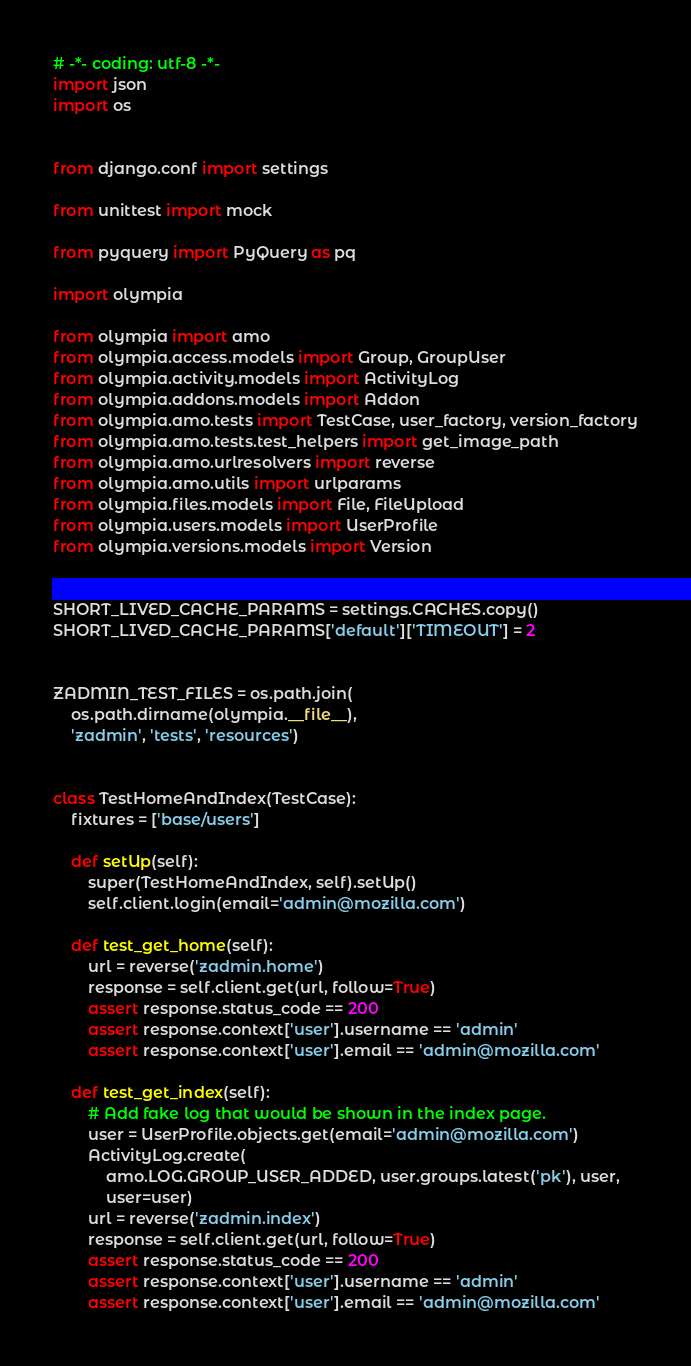Convert code to text. <code><loc_0><loc_0><loc_500><loc_500><_Python_># -*- coding: utf-8 -*-
import json
import os


from django.conf import settings

from unittest import mock

from pyquery import PyQuery as pq

import olympia

from olympia import amo
from olympia.access.models import Group, GroupUser
from olympia.activity.models import ActivityLog
from olympia.addons.models import Addon
from olympia.amo.tests import TestCase, user_factory, version_factory
from olympia.amo.tests.test_helpers import get_image_path
from olympia.amo.urlresolvers import reverse
from olympia.amo.utils import urlparams
from olympia.files.models import File, FileUpload
from olympia.users.models import UserProfile
from olympia.versions.models import Version


SHORT_LIVED_CACHE_PARAMS = settings.CACHES.copy()
SHORT_LIVED_CACHE_PARAMS['default']['TIMEOUT'] = 2


ZADMIN_TEST_FILES = os.path.join(
    os.path.dirname(olympia.__file__),
    'zadmin', 'tests', 'resources')


class TestHomeAndIndex(TestCase):
    fixtures = ['base/users']

    def setUp(self):
        super(TestHomeAndIndex, self).setUp()
        self.client.login(email='admin@mozilla.com')

    def test_get_home(self):
        url = reverse('zadmin.home')
        response = self.client.get(url, follow=True)
        assert response.status_code == 200
        assert response.context['user'].username == 'admin'
        assert response.context['user'].email == 'admin@mozilla.com'

    def test_get_index(self):
        # Add fake log that would be shown in the index page.
        user = UserProfile.objects.get(email='admin@mozilla.com')
        ActivityLog.create(
            amo.LOG.GROUP_USER_ADDED, user.groups.latest('pk'), user,
            user=user)
        url = reverse('zadmin.index')
        response = self.client.get(url, follow=True)
        assert response.status_code == 200
        assert response.context['user'].username == 'admin'
        assert response.context['user'].email == 'admin@mozilla.com'
</code> 